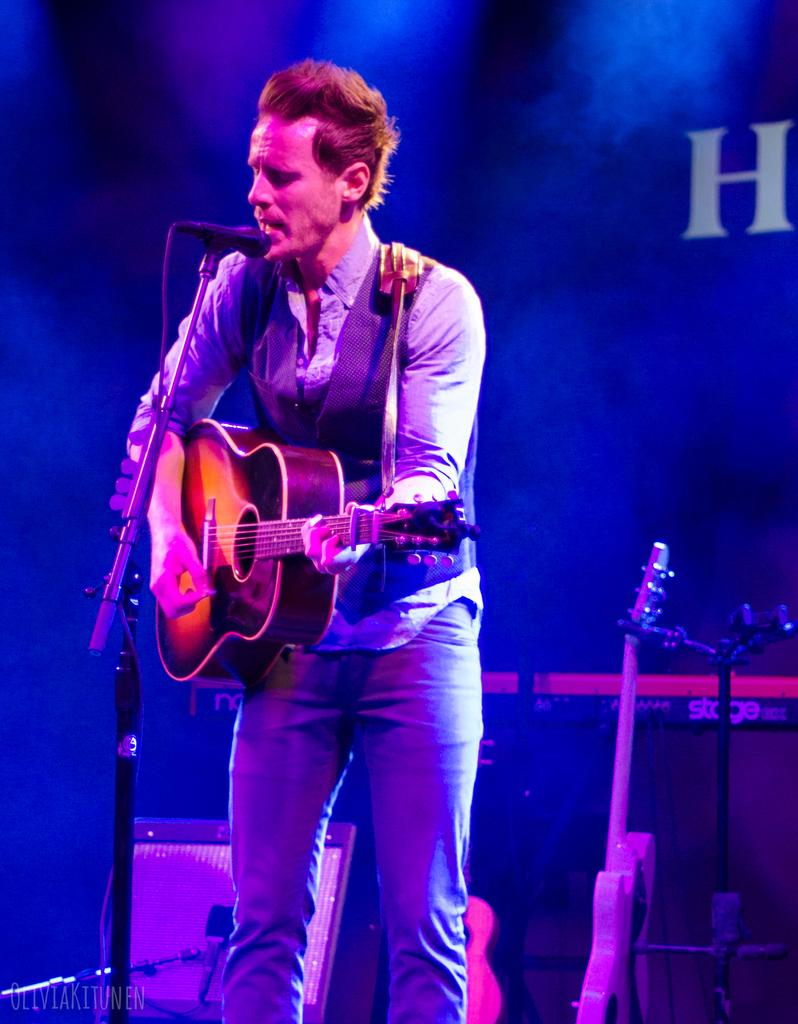What is the man in the image doing? The man is playing a guitar and singing. What instrument is the man using in the image? The man is playing a guitar. What object is present to amplify the man's voice in the image? There is a microphone in the image. What is the purpose of the stand in the image? The stand is likely used to hold the man's sheet music or lyrics. What can be seen in the background of the image? There are guitars and smoke visible in the background of the image. How many plates are visible on the table in the image? There is no table or plates present in the image; it features in the scene include a man playing a guitar, a microphone, a stand, and guitars and smoke in the background. 